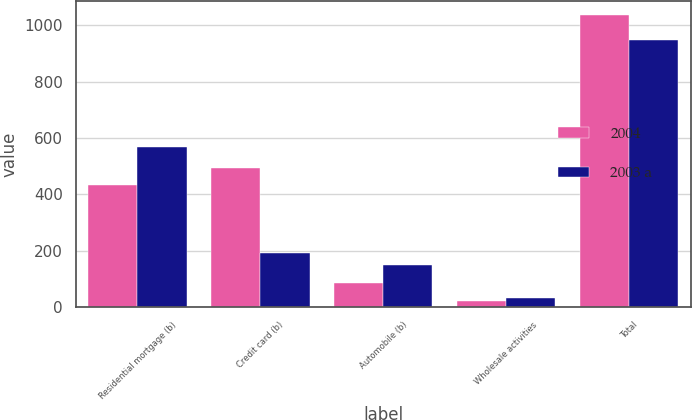<chart> <loc_0><loc_0><loc_500><loc_500><stacked_bar_chart><ecel><fcel>Residential mortgage (b)<fcel>Credit card (b)<fcel>Automobile (b)<fcel>Wholesale activities<fcel>Total<nl><fcel>2004<fcel>433<fcel>494<fcel>85<fcel>23<fcel>1035<nl><fcel>2003 a<fcel>570<fcel>193<fcel>151<fcel>34<fcel>948<nl></chart> 